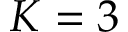<formula> <loc_0><loc_0><loc_500><loc_500>K = 3</formula> 